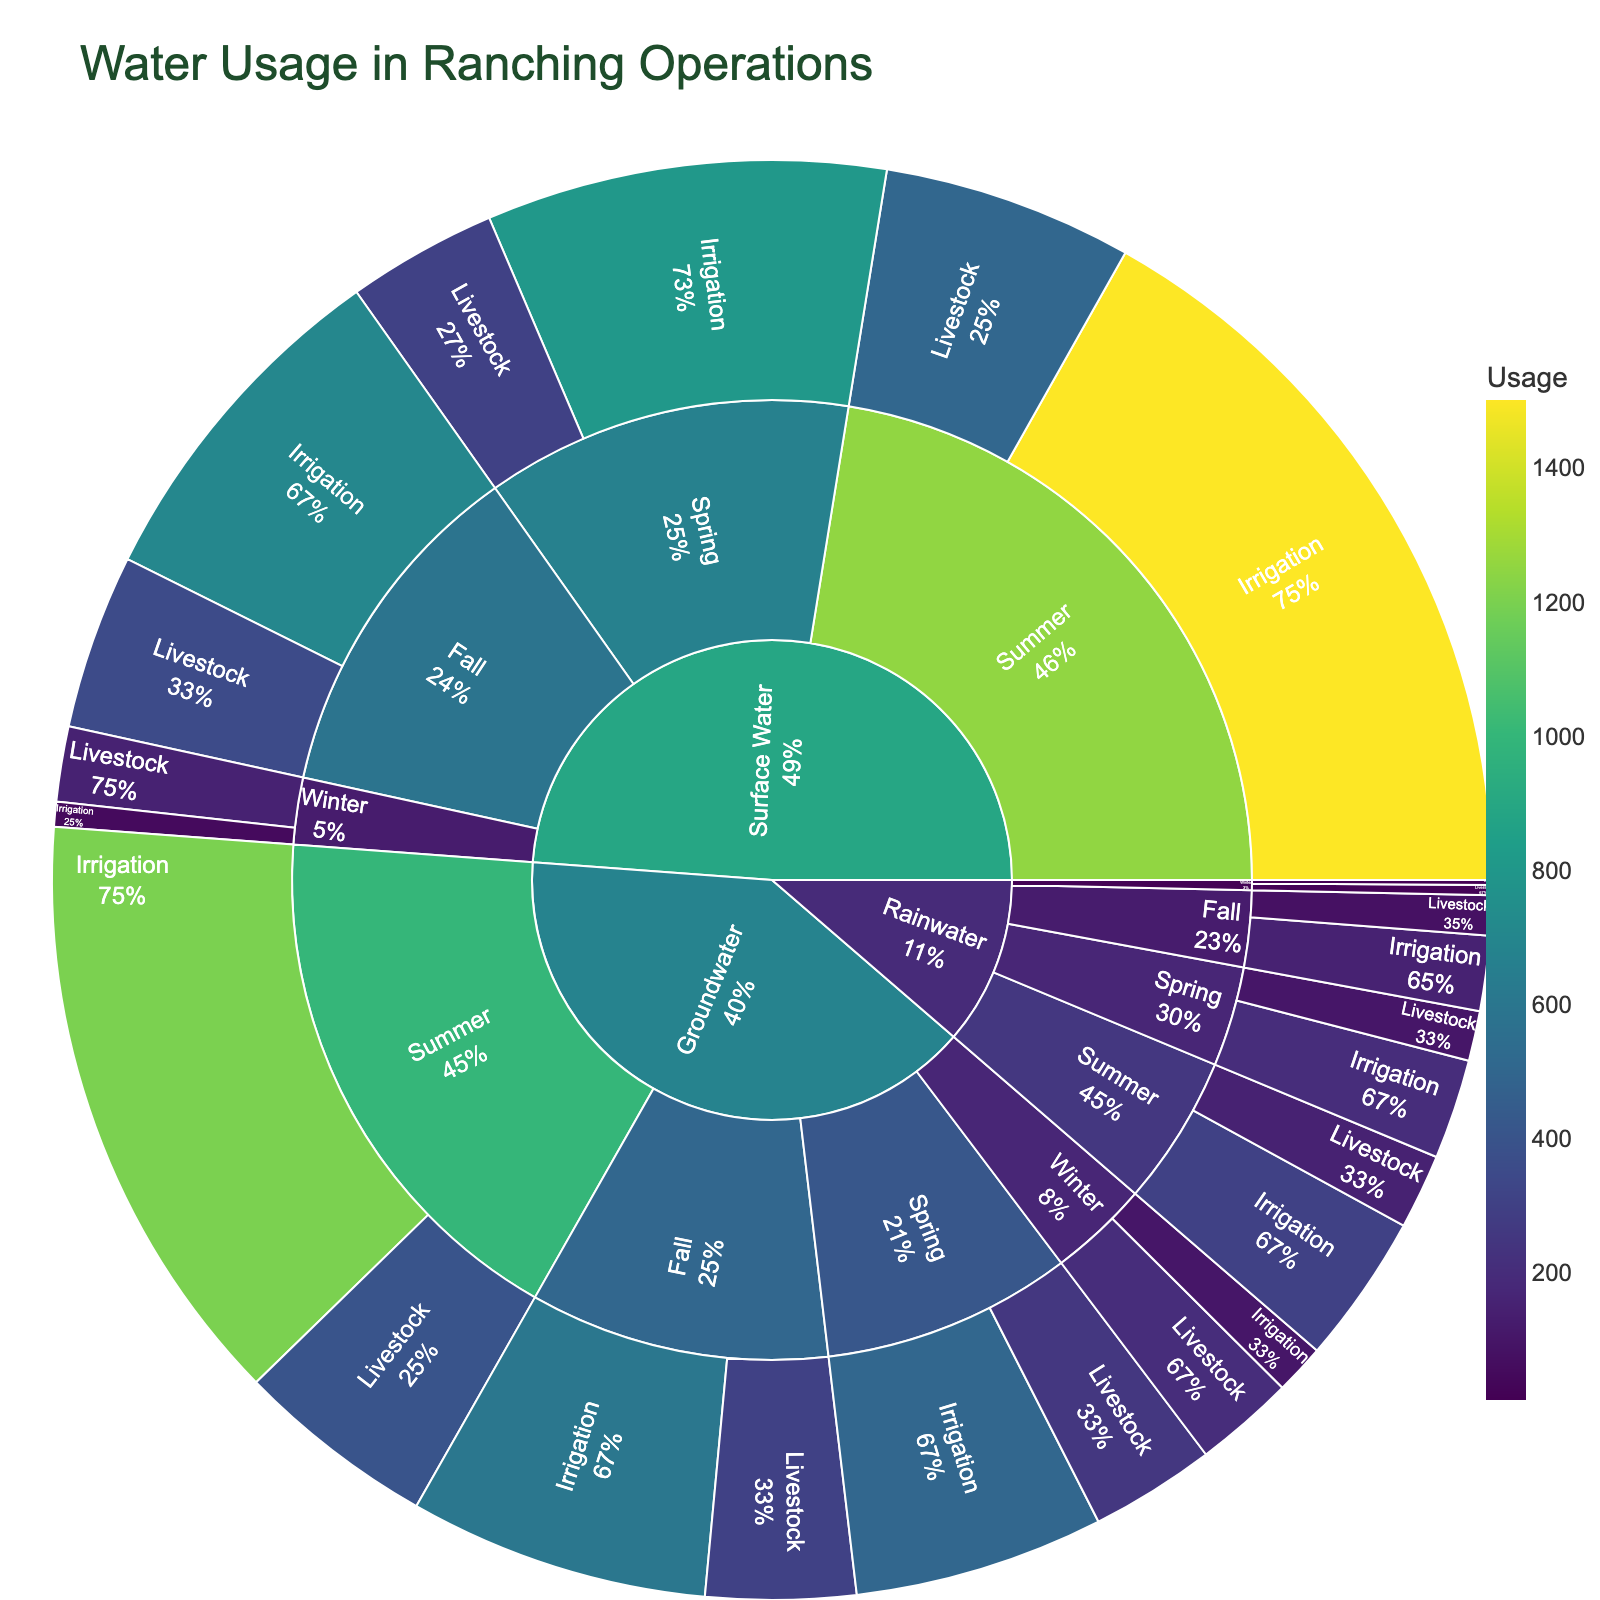What is the title of the plot? The title is located at the top of the plot in a larger and bolder font. It provides context for what the plot represents.
Answer: Water Usage in Ranching Operations Which season has the highest water usage for livestock from surface water? Look for the "Surface Water" section and then examine the relative sizes of the "Livestock" segments within each season.
Answer: Summer How much groundwater is used for livestock in the winter? Navigate through the plot by starting at "Groundwater," then "Winter," and finally "Livestock." The label shows the usage.
Answer: 200 Compare the groundwater usage for irrigation between spring and summer. Which is higher? Navigate to "Groundwater" and compare the "Irrigation" values under "Spring" and "Summer." Observe the usage labels.
Answer: Summer What is the main source of water during spring for irrigation purposes? Begin at the center and break down by "Spring" and then by "Irrigation." The larger the section, the more significant it is.
Answer: Surface Water What is the total water usage in fall for livestock across all sources? Look for the "Fall" segment and sum the "Livestock" usage for Groundwater, Surface Water, and Rainwater. 300 (Groundwater) + 350 (Surface Water) + 80 (Rainwater) = 730
Answer: 730 Which season has the least usage of rainwater for livestock? Examine the "Rainwater" sections and compare the "Livestock" segments across all seasons, observing the smallest.
Answer: Winter Compare the total water usage for livestock and irrigation across all sources in winter. Which purpose has higher usage? Sum the values for both purposes within the "Winter" sections for all sources. Livestock: 200 (Groundwater) + 150 (Surface Water) + 20 (Rainwater) = 370; Irrigation: 100 (Groundwater) + 50 (Surface Water) + 10 (Rainwater) = 160
Answer: Livestock What's the average livestock water usage for rainwater over the entire year? Sum the usage of "Rainwater" for "Livestock" across all seasons and divide by the number of seasons: (100 + 150 + 80 + 20) / 4 = 350 / 4 = 87.5
Answer: 87.5 What is the total irrigation water usage in summer from both groundwater and surface water sources combined? Add up the usage for "Irrigation" under "Summer" for both "Groundwater" and "Surface Water." Groundwater: 1200, Surface Water: 1500. 1200 + 1500 = 2700
Answer: 2700 